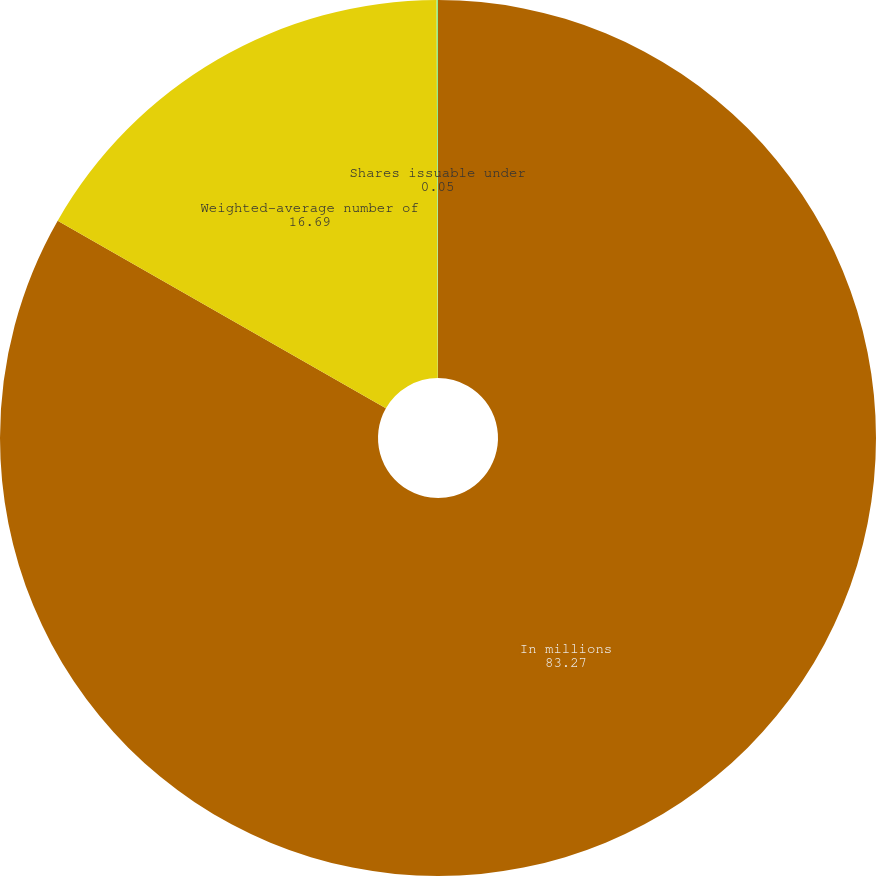Convert chart to OTSL. <chart><loc_0><loc_0><loc_500><loc_500><pie_chart><fcel>In millions<fcel>Weighted-average number of<fcel>Shares issuable under<nl><fcel>83.27%<fcel>16.69%<fcel>0.05%<nl></chart> 